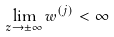Convert formula to latex. <formula><loc_0><loc_0><loc_500><loc_500>\lim _ { z \rightarrow \pm \infty } w ^ { ( j ) } < \infty</formula> 